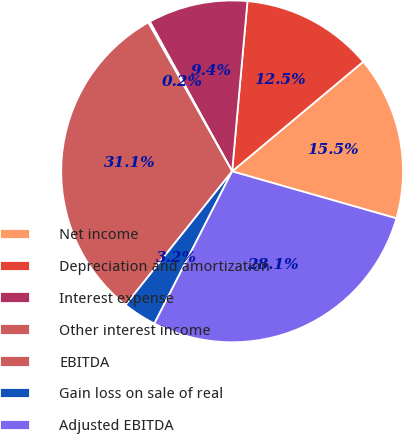Convert chart to OTSL. <chart><loc_0><loc_0><loc_500><loc_500><pie_chart><fcel>Net income<fcel>Depreciation and amortization<fcel>Interest expense<fcel>Other interest income<fcel>EBITDA<fcel>Gain loss on sale of real<fcel>Adjusted EBITDA<nl><fcel>15.52%<fcel>12.48%<fcel>9.43%<fcel>0.16%<fcel>31.12%<fcel>3.2%<fcel>28.08%<nl></chart> 